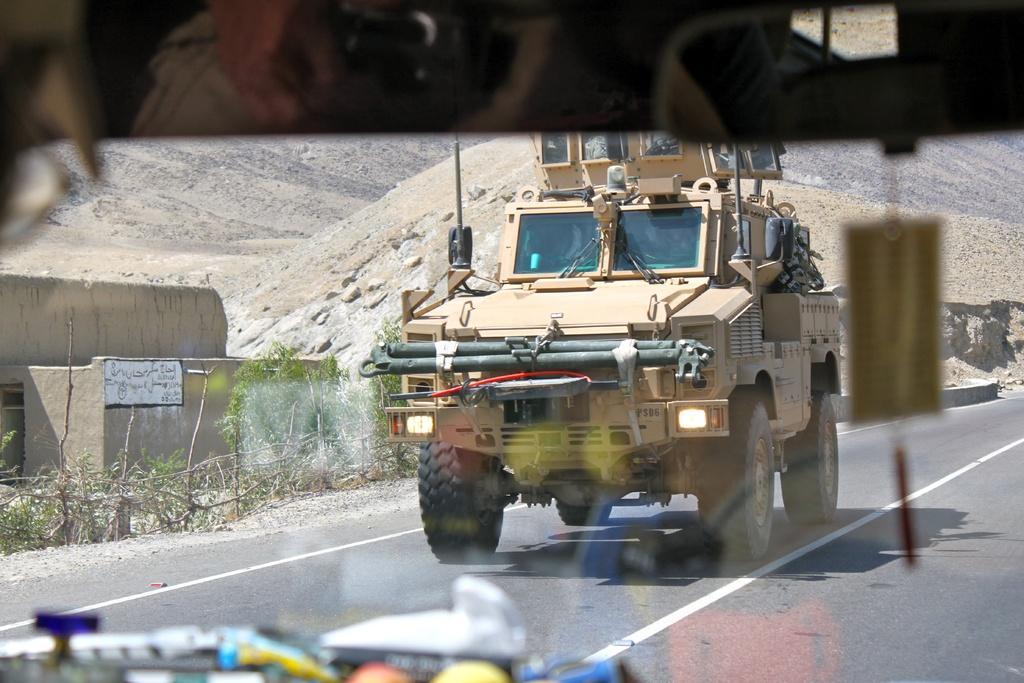How would you summarize this image in a sentence or two? In this image we can see the mirror of one vehicle, there we can see an object hanging from the roof of the car and some objects, behind the vehicle we see another vehicle on the road, there we can also see few plants, a small fence, a wall, stones and mountains. 